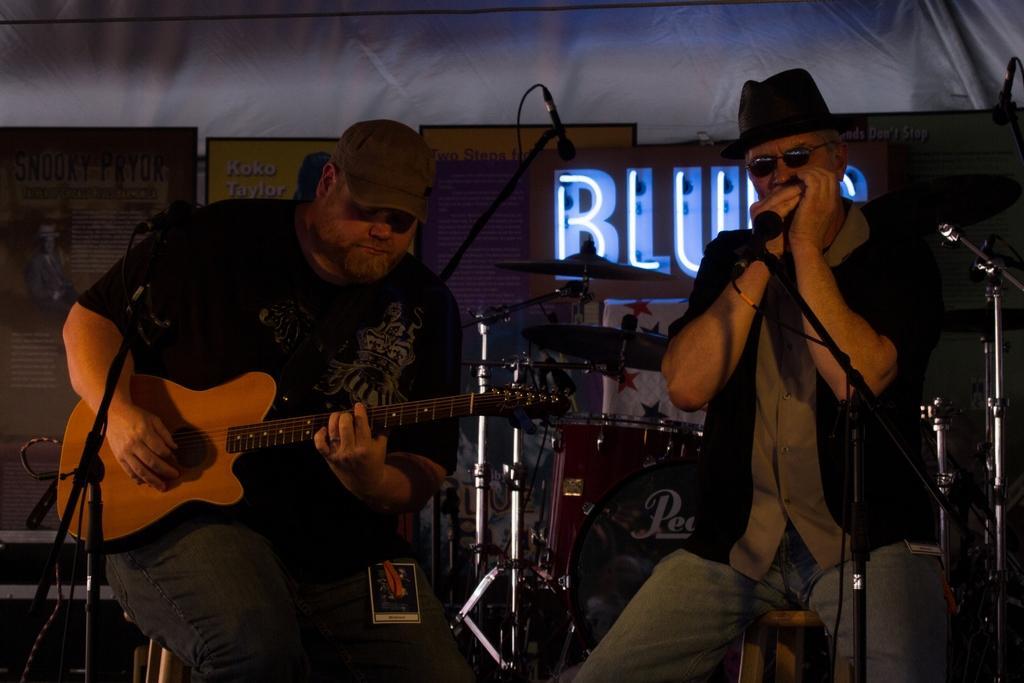How would you summarize this image in a sentence or two? In this image I see a man who is holding a guitar and he is in front of the mic, I can also see another man who is sitting in front of a mic. I see that both of them are wearing caps and this man is wearing shades. In the background I see the shades. 